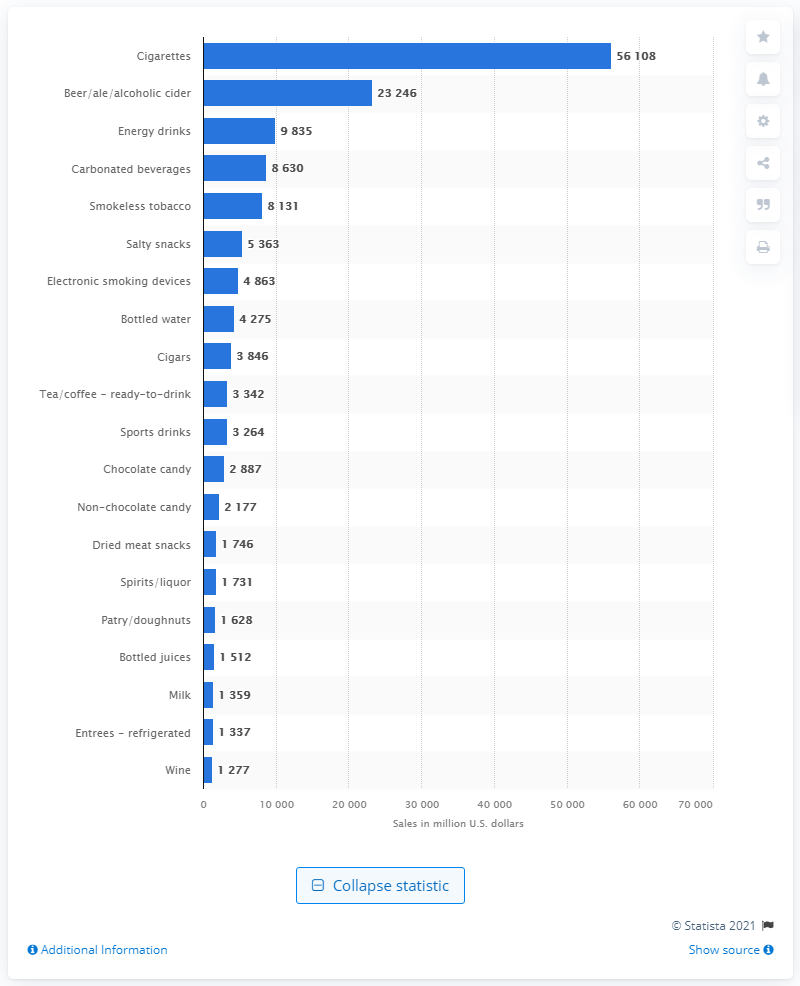Point out several critical features in this image. In 2020, convenience stores and gas stations sold a total of 56,108 dollars' worth of cigarettes. 